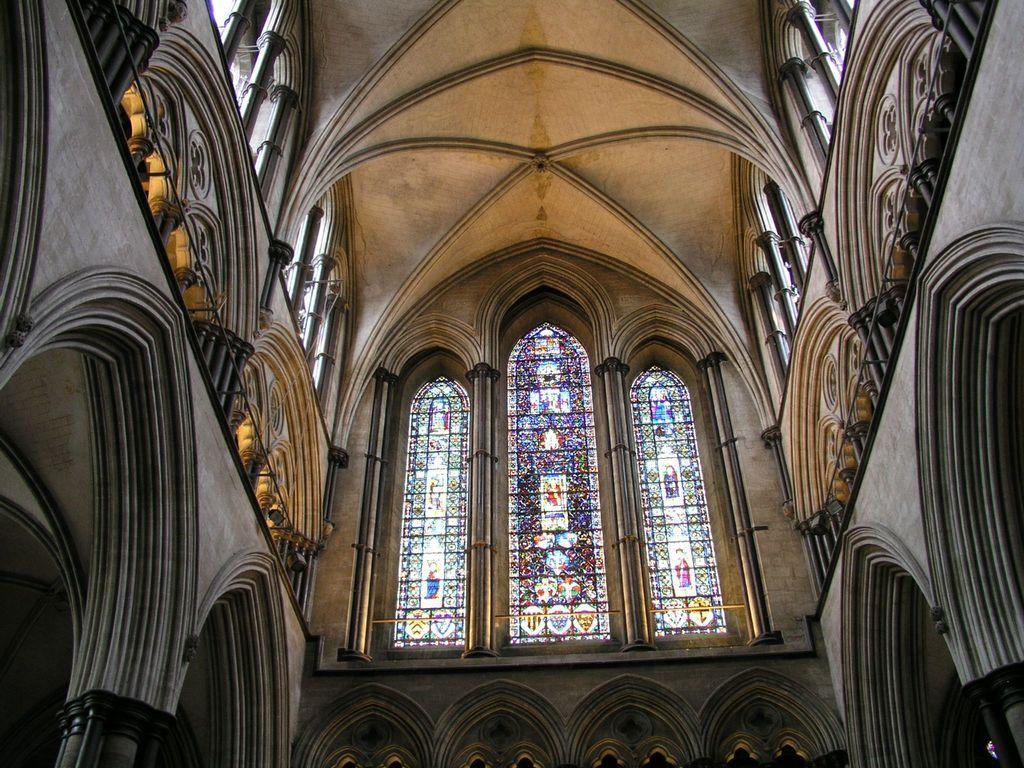Could you give a brief overview of what you see in this image? This is the inner view of a building. We can see some arches and pillars. We can also see the walls. We can see some glass and the roof. 